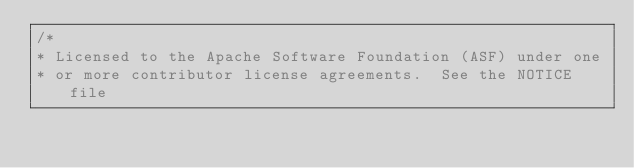<code> <loc_0><loc_0><loc_500><loc_500><_TypeScript_>/*
* Licensed to the Apache Software Foundation (ASF) under one
* or more contributor license agreements.  See the NOTICE file</code> 